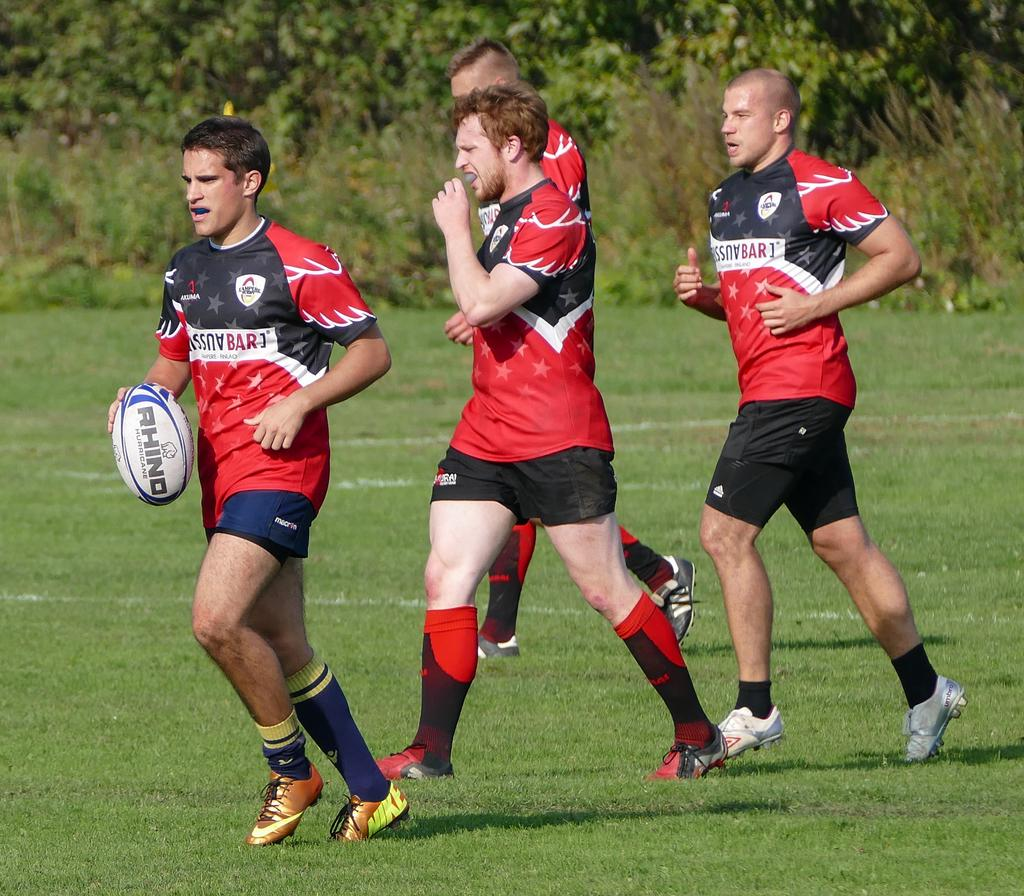How many people are in the image? There are people in the image. What are the people wearing? The people are wearing sports dress. What are the people doing in the image? The people are running. Can you describe the person holding an object? One of the people is holding a ball. What is visible at the bottom of the image? There is ground visible at the bottom of the image. What can be seen in the background of the image? There are trees in the background of the image. Where is the queen sleeping in the image? There is no queen or sleeping area present in the image. Can you tell me how many cellars are visible in the image? There are no cellars visible in the image. 